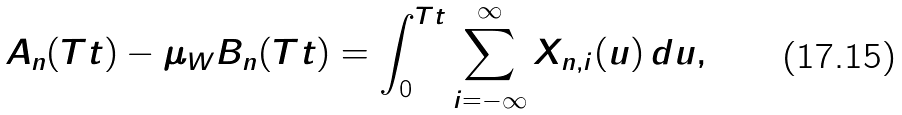<formula> <loc_0><loc_0><loc_500><loc_500>A _ { n } ( T t ) - \mu _ { W } B _ { n } ( T t ) = \int _ { 0 } ^ { T t } \sum _ { i = - \infty } ^ { \infty } X _ { n , i } ( u ) \, d u ,</formula> 